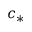Convert formula to latex. <formula><loc_0><loc_0><loc_500><loc_500>c _ { * }</formula> 